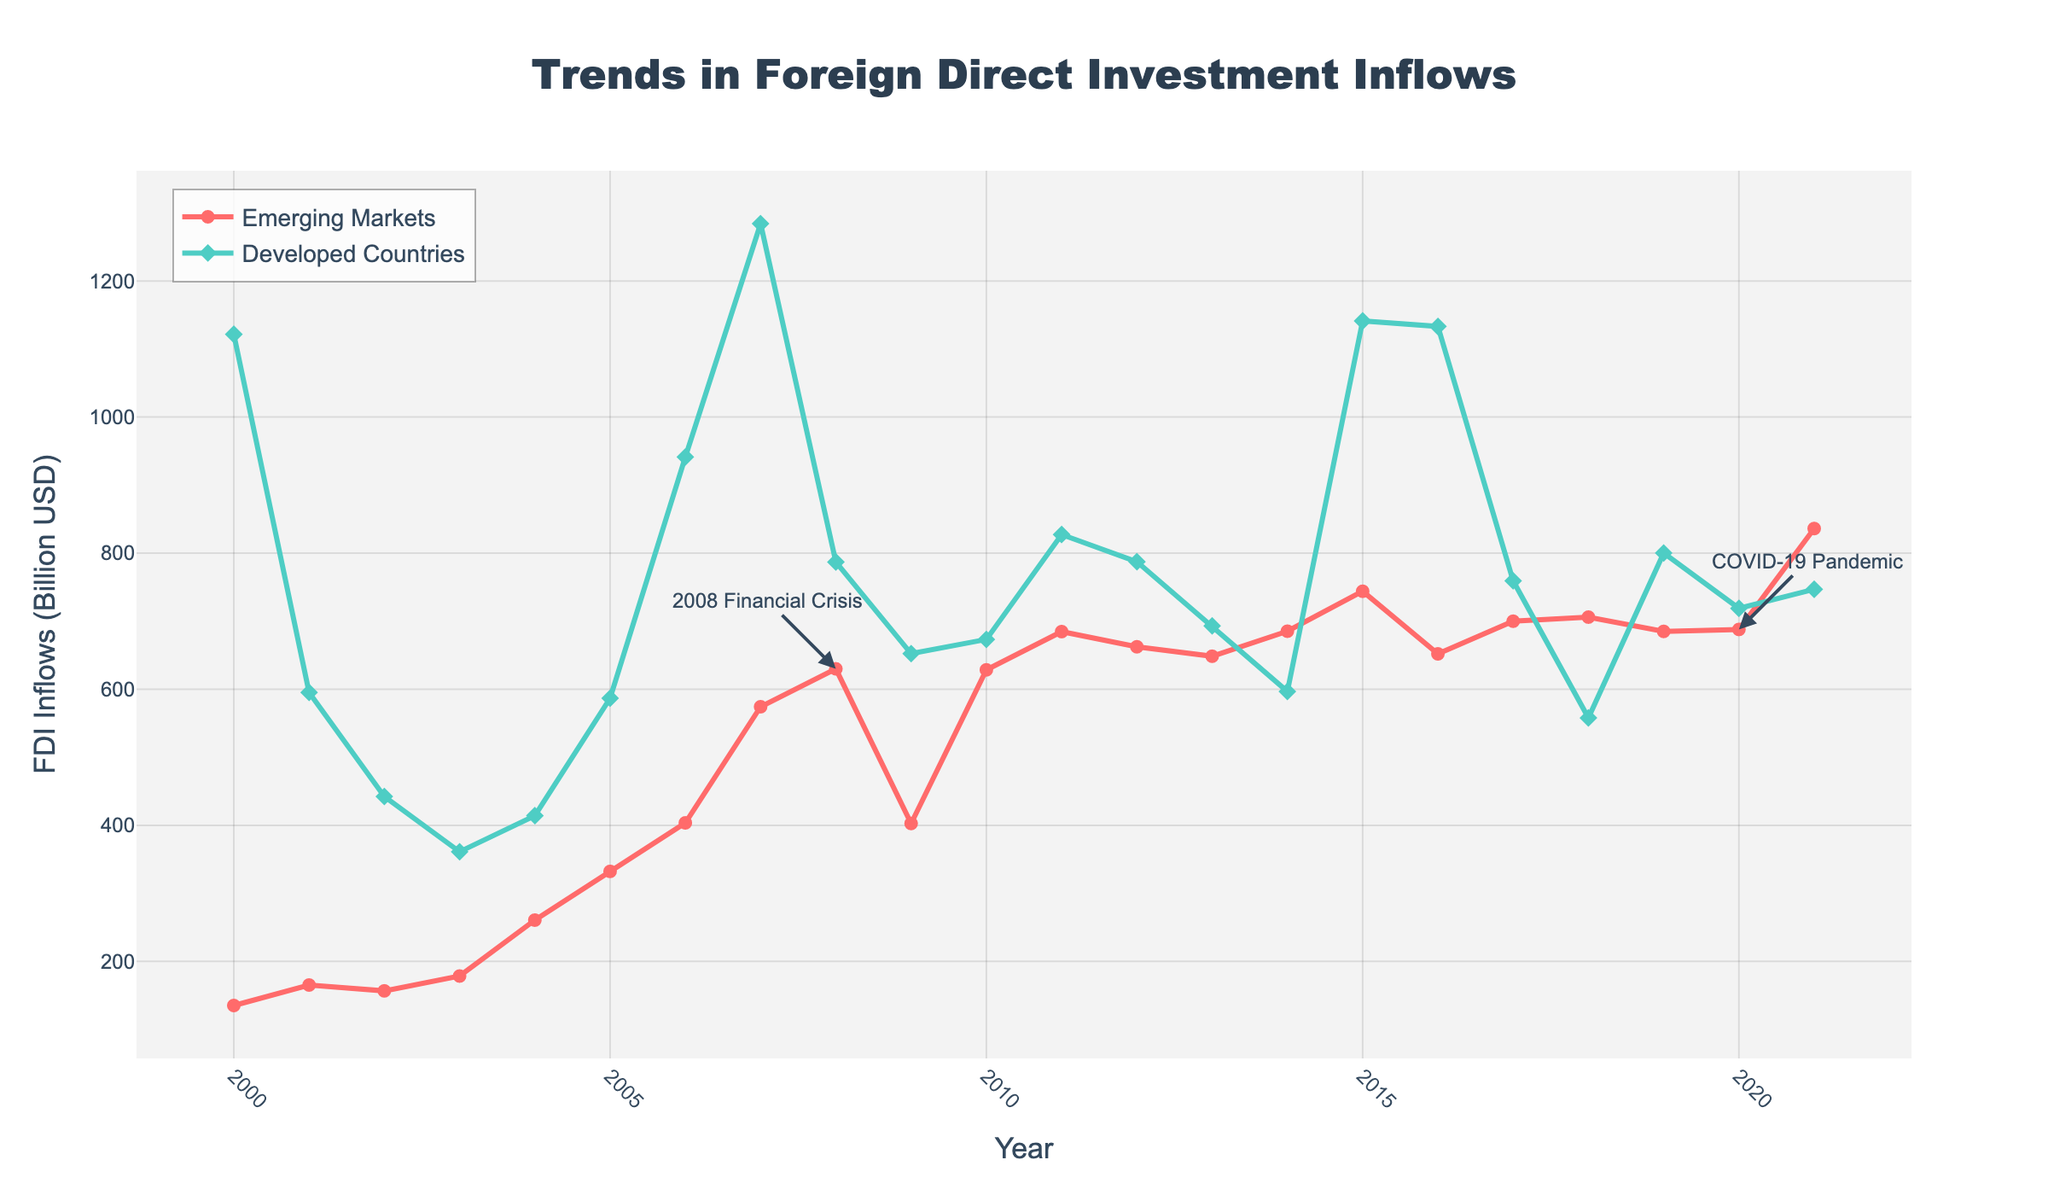What's the difference in FDI inflows between Emerging Markets and Developed Countries in 2008? The FDI inflows for Emerging Markets in 2008 is $630 billion, and for Developed Countries, it is $787 billion. The difference is calculated as $787 billion - $630 billion = $157 billion.
Answer: $157 billion How did the FDI inflows for Emerging Markets change from 2000 to 2021? In 2000, the FDI inflows for Emerging Markets were $135.2 billion. By 2021, this increased to $836.2 billion. The change is calculated as $836.2 billion - $135.2 billion = $701 billion.
Answer: $701 billion Which year had the highest FDI inflows for Developed Countries, and what was the value? The highest FDI inflows for Developed Countries were seen in 2007, with a value of $1284.3 billion, as indicated by the peak in the green line.
Answer: 2007, $1284.3 billion During which years did Emerging Markets experience a decline in FDI inflows consecutively? A consecutive decline in FDI inflows for Emerging Markets is observed from 2008 ($630 billion) to 2009 ($402.7 billion) and from 2011 ($684.7 billion) to 2012 ($662.4 billion).
Answer: 2008-2009 and 2011-2012 Compare the FDI inflows for Emerging Markets and Developed Countries in 2001. Which was greater and by how much? In 2001, Emerging Markets had FDI inflows of $165.3 billion, while Developed Countries had $595.3 billion. Developed Countries had greater inflows by $595.3 billion - $165.3 billion = $430 billion.
Answer: Developed Countries by $430 billion Identify the years where the FDI inflows for Emerging Markets were higher than those for Developed Countries. By comparing the figures year by year, Emerging Markets had higher FDI inflows in the years 2013, 2014, 2017, 2018, 2020, and 2021.
Answer: 2013, 2014, 2017, 2018, 2020, 2021 What is the average FDI inflow for Developed Countries from 2000 to 2021? Sum all the FDI inflows for Developed Countries from 2000 to 2021: 1121.7, 595.3, 442.3, 361.2, 414.2, 586.8, 941.4, 1284.3, 787.0, 652.3, 673.2, 827.4, 787.4, 693.2, 596.7, 1141.3, 1133.2, 759.3, 557.9, 800.2, 718.9, 746.9. The total is 17422.8, and there are 22 data points. The average is 17422.8 / 22 = 791.04 billion USD.
Answer: $791.04 billion What visual annotation exists in the figure to mark specific economic events, and what years do they highlight? The figure contains annotations marking the 2008 Financial Crisis and the COVID-19 Pandemic, highlighting the years 2008 and 2020, respectively.
Answer: 2008 and 2020 